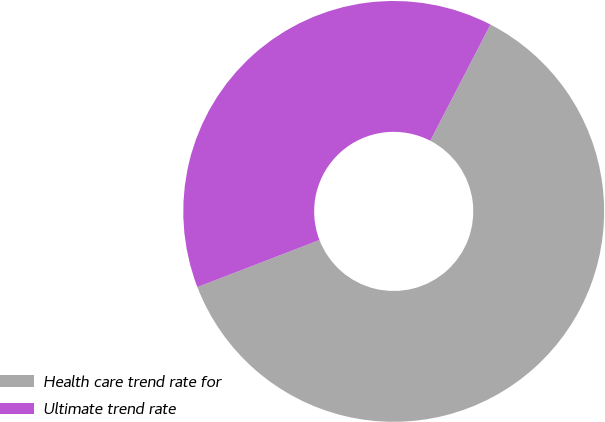Convert chart. <chart><loc_0><loc_0><loc_500><loc_500><pie_chart><fcel>Health care trend rate for<fcel>Ultimate trend rate<nl><fcel>61.54%<fcel>38.46%<nl></chart> 